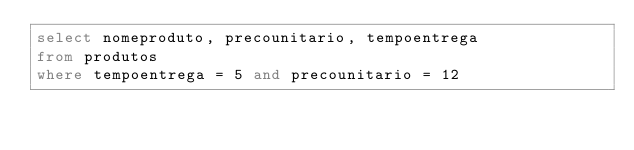<code> <loc_0><loc_0><loc_500><loc_500><_SQL_>select nomeproduto, precounitario, tempoentrega
from produtos
where tempoentrega = 5 and precounitario = 12</code> 